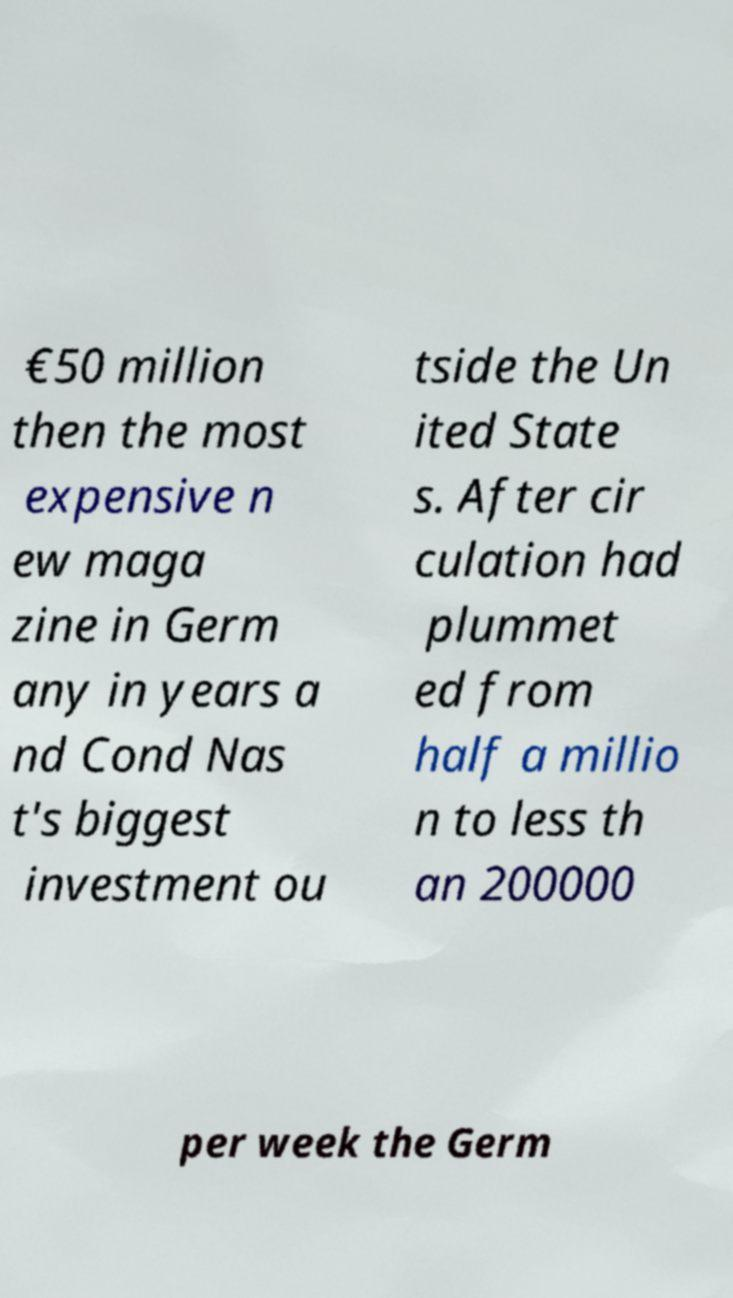Can you read and provide the text displayed in the image?This photo seems to have some interesting text. Can you extract and type it out for me? €50 million then the most expensive n ew maga zine in Germ any in years a nd Cond Nas t's biggest investment ou tside the Un ited State s. After cir culation had plummet ed from half a millio n to less th an 200000 per week the Germ 